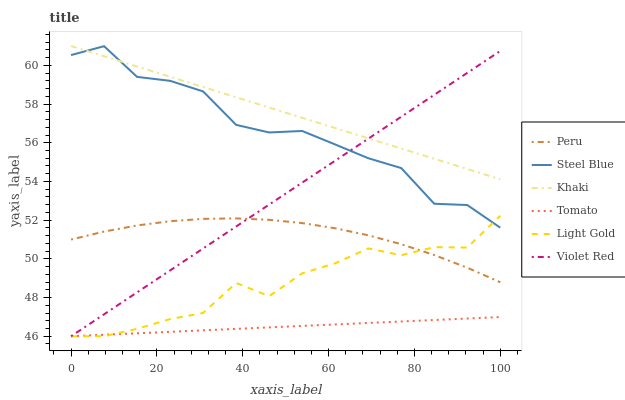Does Tomato have the minimum area under the curve?
Answer yes or no. Yes. Does Khaki have the maximum area under the curve?
Answer yes or no. Yes. Does Violet Red have the minimum area under the curve?
Answer yes or no. No. Does Violet Red have the maximum area under the curve?
Answer yes or no. No. Is Violet Red the smoothest?
Answer yes or no. Yes. Is Steel Blue the roughest?
Answer yes or no. Yes. Is Khaki the smoothest?
Answer yes or no. No. Is Khaki the roughest?
Answer yes or no. No. Does Tomato have the lowest value?
Answer yes or no. Yes. Does Khaki have the lowest value?
Answer yes or no. No. Does Khaki have the highest value?
Answer yes or no. Yes. Does Violet Red have the highest value?
Answer yes or no. No. Is Tomato less than Steel Blue?
Answer yes or no. Yes. Is Khaki greater than Peru?
Answer yes or no. Yes. Does Steel Blue intersect Light Gold?
Answer yes or no. Yes. Is Steel Blue less than Light Gold?
Answer yes or no. No. Is Steel Blue greater than Light Gold?
Answer yes or no. No. Does Tomato intersect Steel Blue?
Answer yes or no. No. 